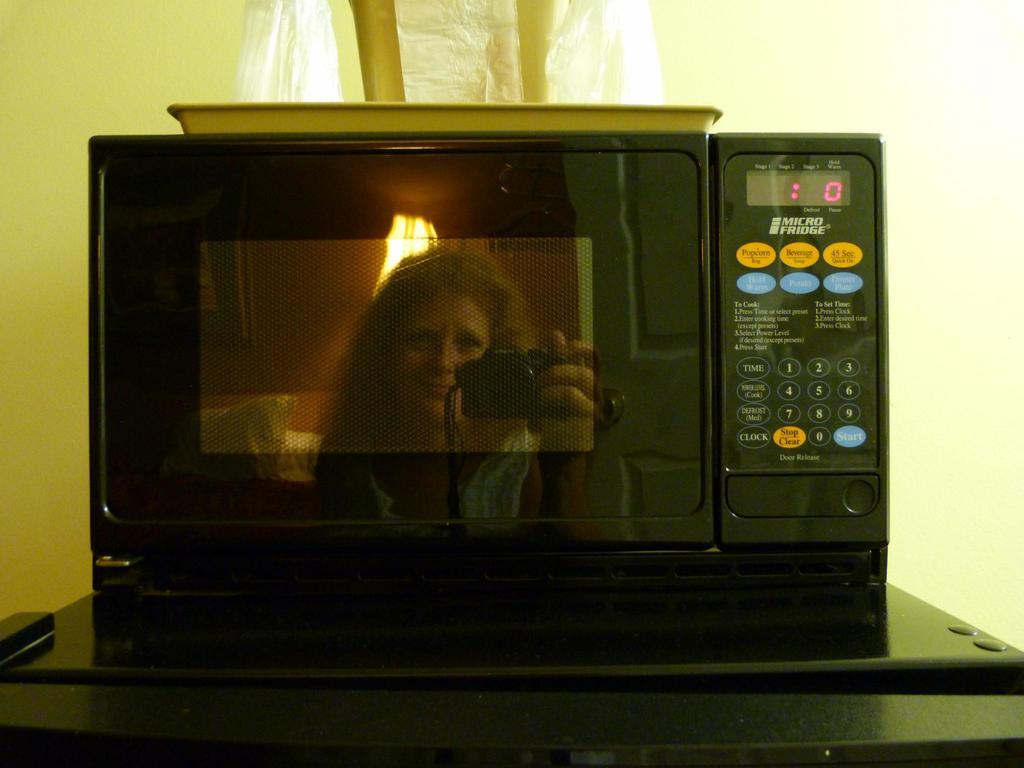<image>
Render a clear and concise summary of the photo. A microwave that says Micro Fridge on it and has buttons such as one for popcorn and one for beverages on it. 